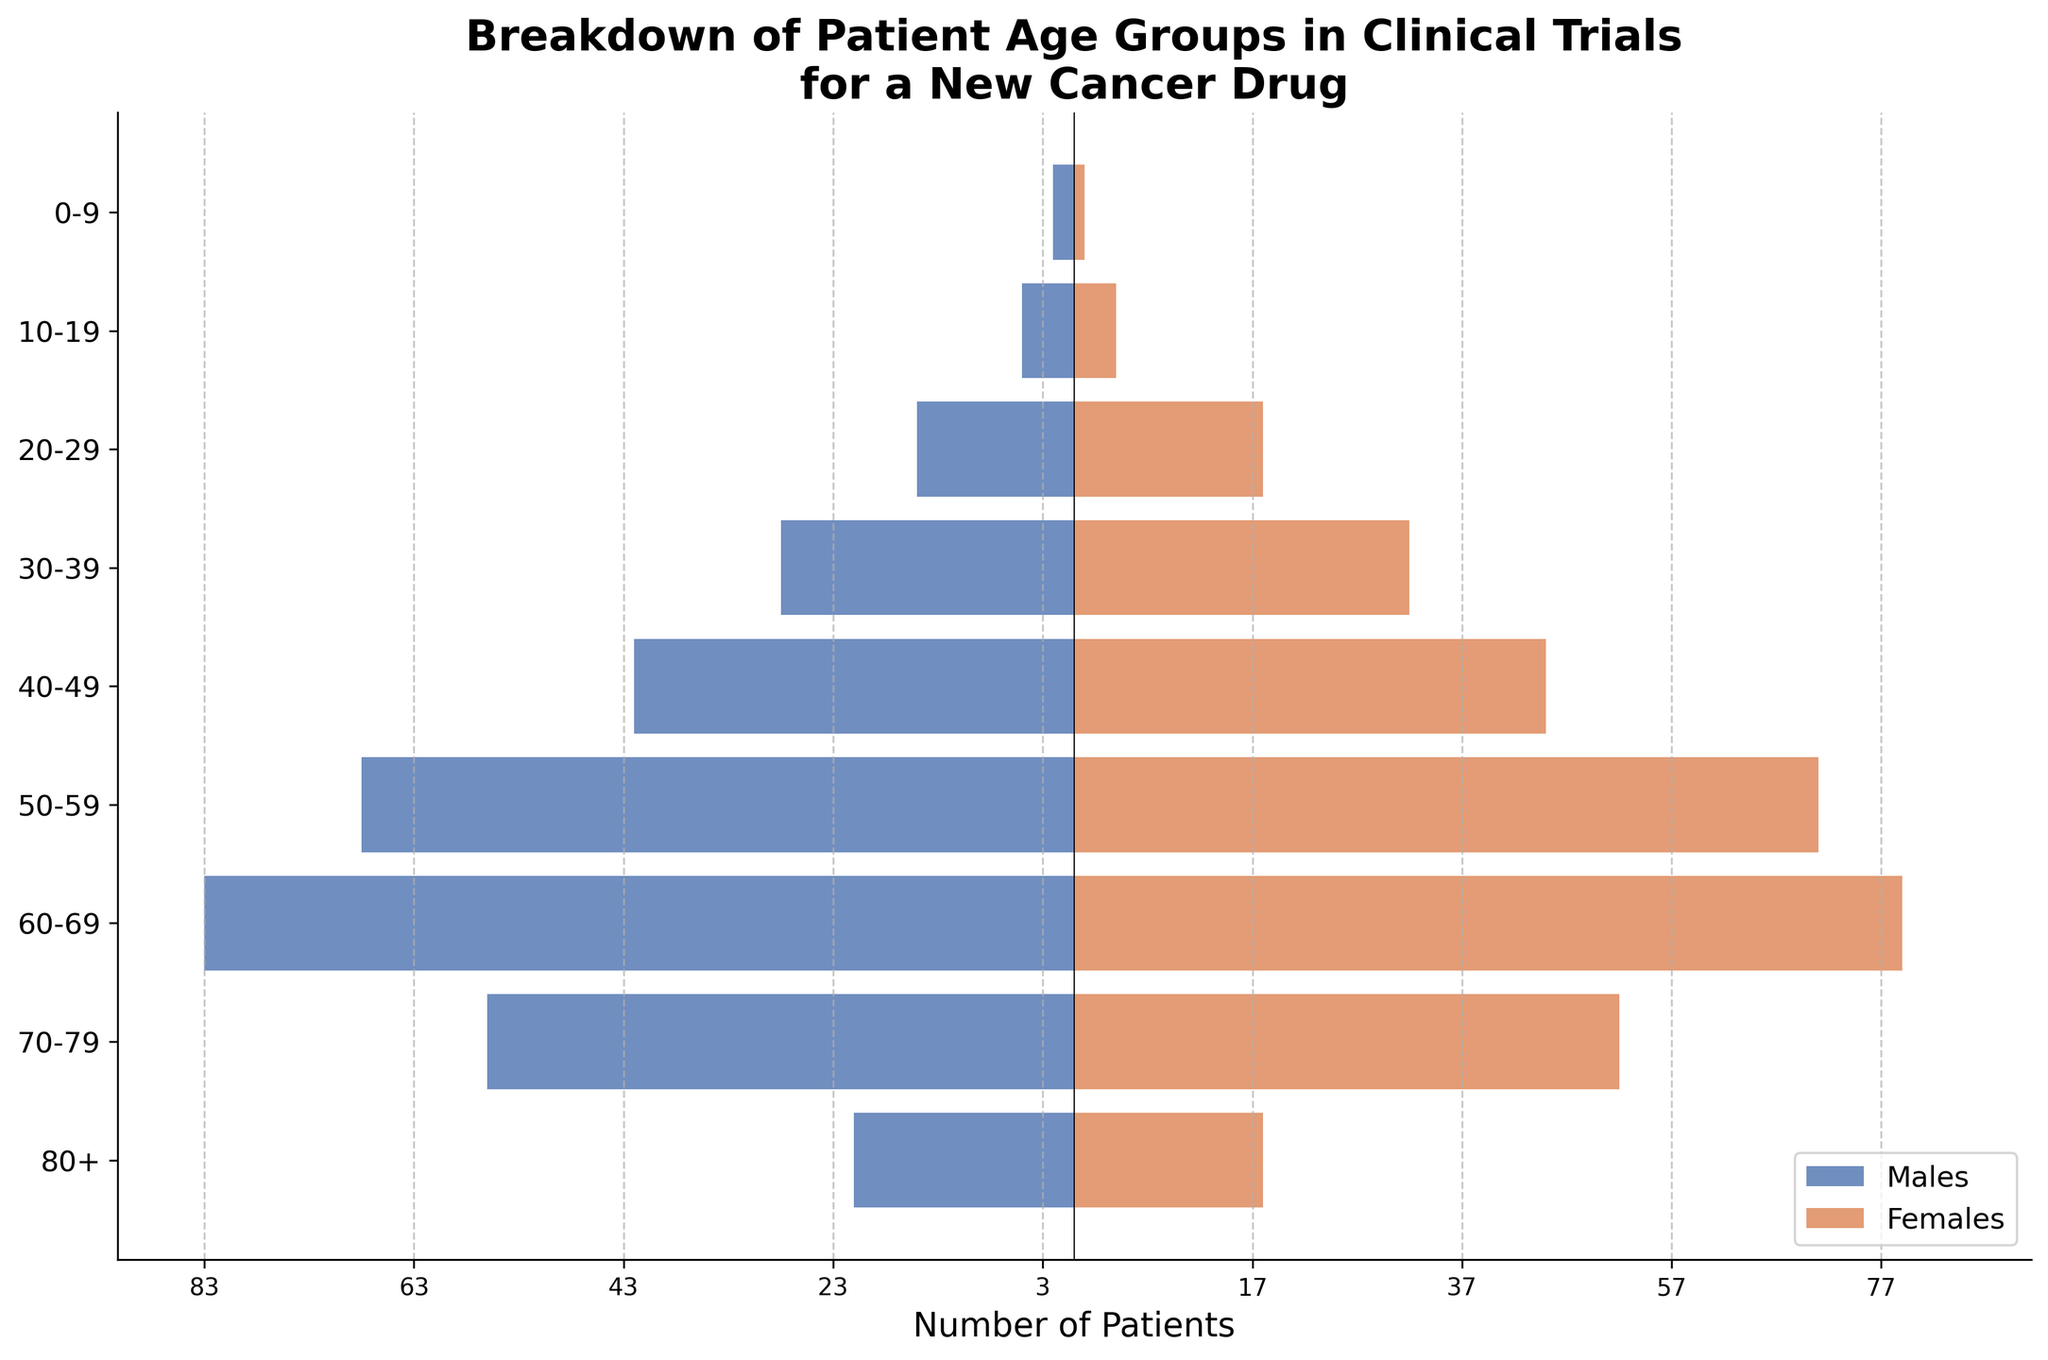What is the title of the figure? The title of a chart is usually found at the top and gives a brief description of the data being represented. In this case, it describes the data breakdown by age group in clinical trials for a new cancer drug.
Answer: Breakdown of Patient Age Groups in Clinical Trials for a New Cancer Drug Which age group has the highest number of male patients? To find the age group with the highest count of male patients, observe the lengths of the bars on the left (negative side). The longest bar represents the group with the most patients.
Answer: 60-69 How many females are in the 50-59 age group? Look at the bar for the 50-59 age group on the right side (positive side) of the chart, which represents the number of female patients.
Answer: 71 What is the sum of male patients in the 60-69 and 50-59 age groups? Add the values for the 60-69 and 50-59 male age groups. From the left side of the chart, 60-69 has 83 and 50-59 has 68. Sum these: 83 + 68.
Answer: 151 Which age group has fewer males than females? Compare the length of the bars for each age group on both sides. Look for bars on the right side (females) that are longer than those on the left side (males).
Answer: 20-29 What is the difference in the number of patients between males and females in the 70-79 age group? Subtract the number of female patients from the number of male patients in this age group. The bar for males in this group is at 56, while for females, it is at 52. The difference is 56 - 52.
Answer: 4 How many total patients are in the age group 80+? Sum the number of male and female patients for the 80+ age group. The chart shows 21 males and 18 females. Add these: 21 + 18.
Answer: 39 Which age group has the closest number of males and females? Look for the age group where the lengths of the bars on both sides are closest in magnitude.
Answer: 40-49 What is the total number of patients in the age group 0-9? Add the number of male and female patients in the 0-9 age group. The chart shows 2 males and 1 female. Add these: 2 + 1.
Answer: 3 In which age group is the discrepancy between the number of males and females the greatest? Find the age group where the difference between the length of the male and female bars is the largest. Calculate for each age group if visual inspection is not clear.
Answer: 60-69 